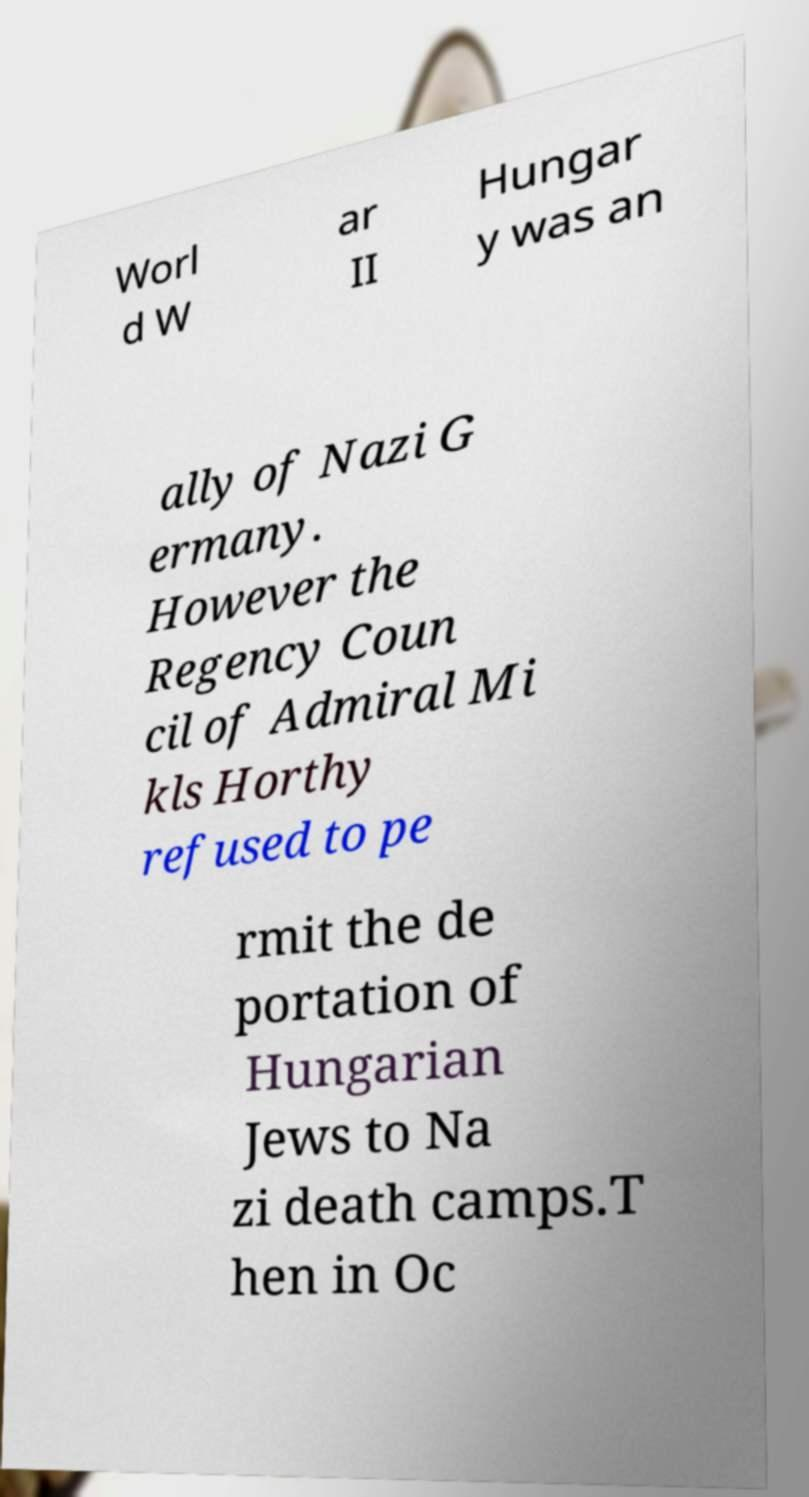Please read and relay the text visible in this image. What does it say? Worl d W ar II Hungar y was an ally of Nazi G ermany. However the Regency Coun cil of Admiral Mi kls Horthy refused to pe rmit the de portation of Hungarian Jews to Na zi death camps.T hen in Oc 